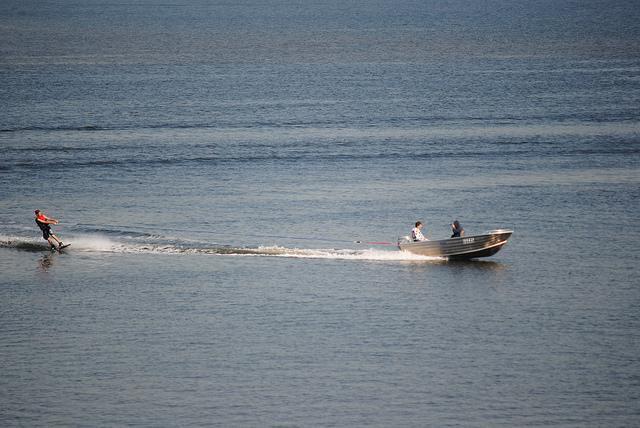How many people are shown?
Give a very brief answer. 3. 